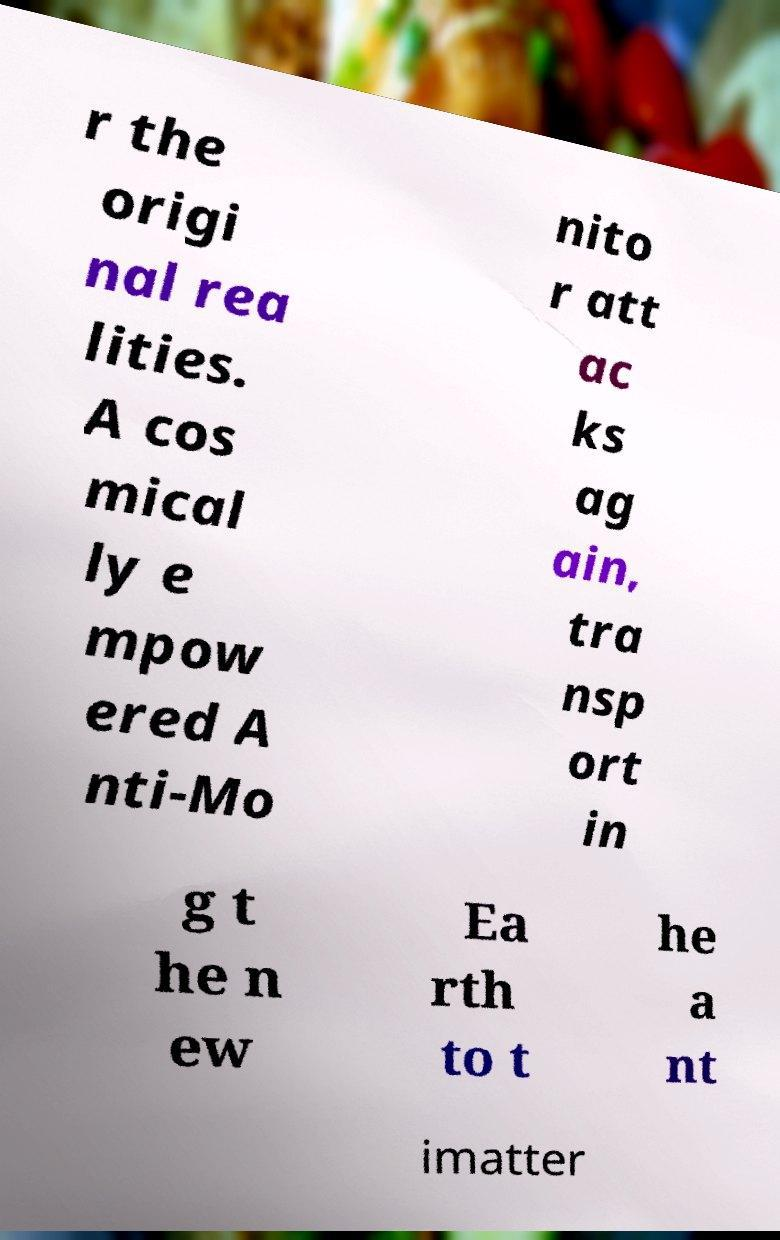Could you assist in decoding the text presented in this image and type it out clearly? r the origi nal rea lities. A cos mical ly e mpow ered A nti-Mo nito r att ac ks ag ain, tra nsp ort in g t he n ew Ea rth to t he a nt imatter 